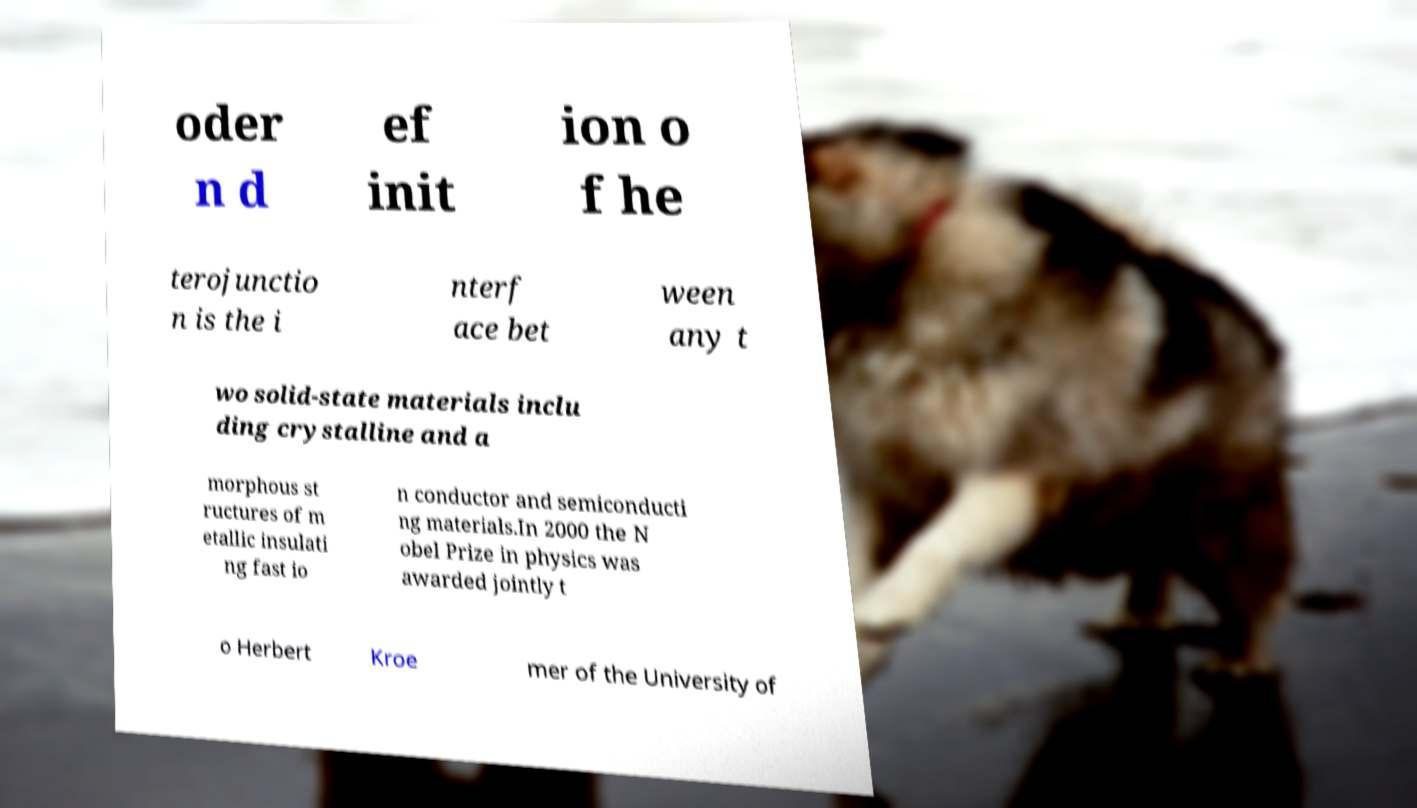Please identify and transcribe the text found in this image. oder n d ef init ion o f he terojunctio n is the i nterf ace bet ween any t wo solid-state materials inclu ding crystalline and a morphous st ructures of m etallic insulati ng fast io n conductor and semiconducti ng materials.In 2000 the N obel Prize in physics was awarded jointly t o Herbert Kroe mer of the University of 